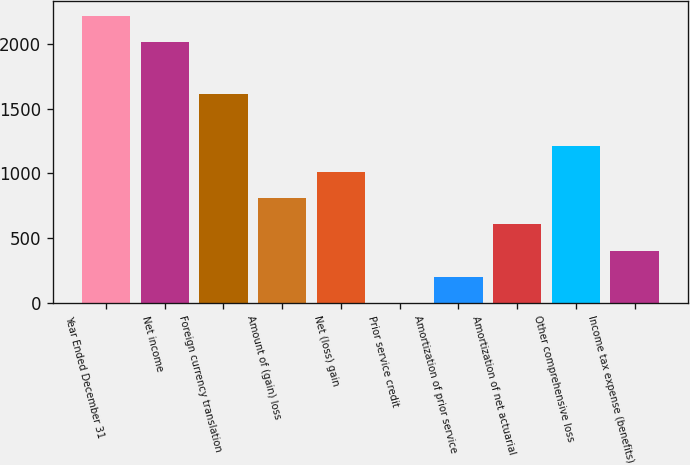Convert chart. <chart><loc_0><loc_0><loc_500><loc_500><bar_chart><fcel>Year Ended December 31<fcel>Net income<fcel>Foreign currency translation<fcel>Amount of (gain) loss<fcel>Net (loss) gain<fcel>Prior service credit<fcel>Amortization of prior service<fcel>Amortization of net actuarial<fcel>Other comprehensive loss<fcel>Income tax expense (benefits)<nl><fcel>2216.4<fcel>2015<fcel>1612.2<fcel>806.6<fcel>1008<fcel>1<fcel>202.4<fcel>605.2<fcel>1209.4<fcel>403.8<nl></chart> 